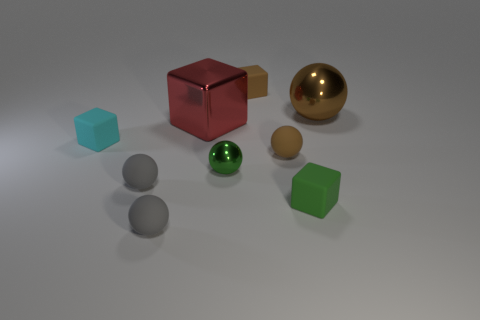Subtract all metallic balls. How many balls are left? 3 Subtract all yellow blocks. How many gray balls are left? 2 Subtract all balls. How many objects are left? 4 Subtract all cyan blocks. How many blocks are left? 3 Subtract 3 blocks. How many blocks are left? 1 Subtract all small cubes. Subtract all big red rubber blocks. How many objects are left? 6 Add 3 tiny green metallic things. How many tiny green metallic things are left? 4 Add 7 cyan objects. How many cyan objects exist? 8 Subtract 0 blue blocks. How many objects are left? 9 Subtract all blue cubes. Subtract all purple balls. How many cubes are left? 4 